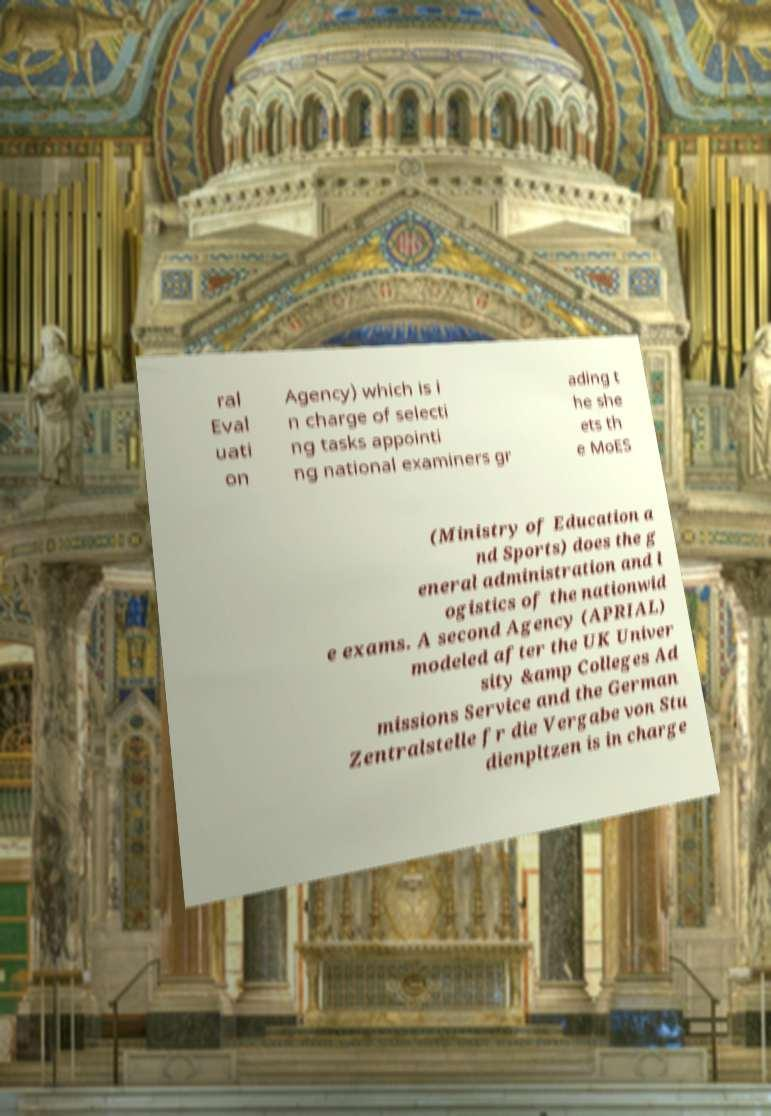Please identify and transcribe the text found in this image. ral Eval uati on Agency) which is i n charge of selecti ng tasks appointi ng national examiners gr ading t he she ets th e MoES (Ministry of Education a nd Sports) does the g eneral administration and l ogistics of the nationwid e exams. A second Agency (APRIAL) modeled after the UK Univer sity &amp Colleges Ad missions Service and the German Zentralstelle fr die Vergabe von Stu dienpltzen is in charge 